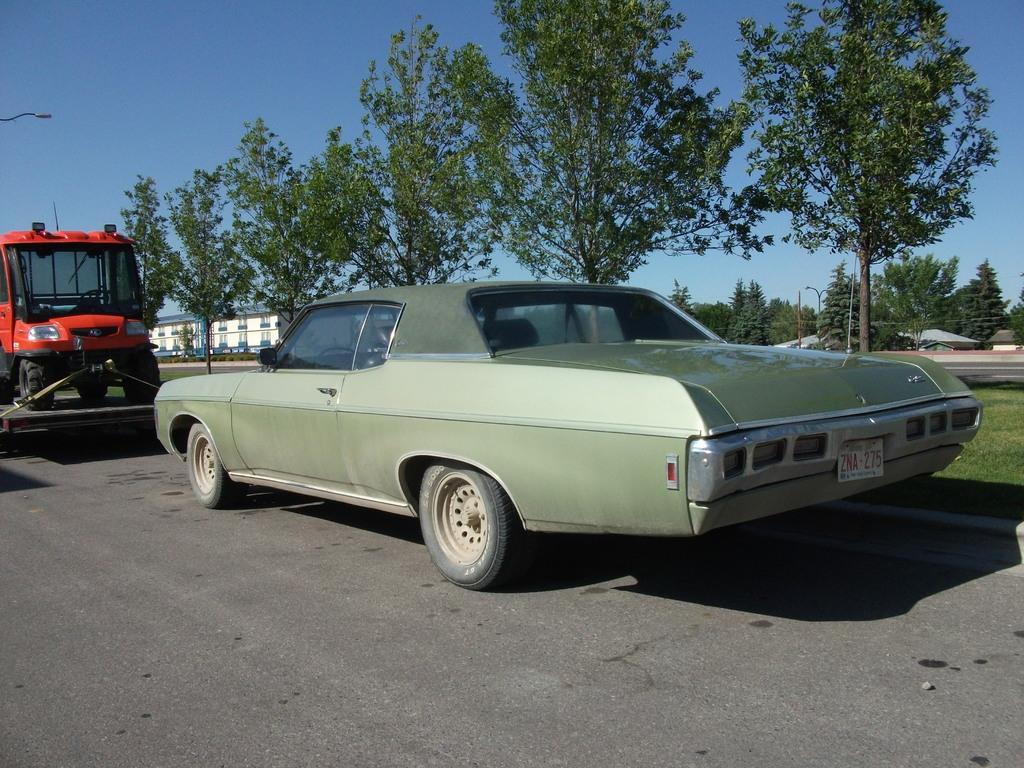Could you give a brief overview of what you see in this image? In this picture I can see the road in front, on which I can see a car and a vehicle on a thing. In the background I can see number of trees and few light poles. I can also see the buildings and the clear sky. On the right side of this picture I can see the grass. 